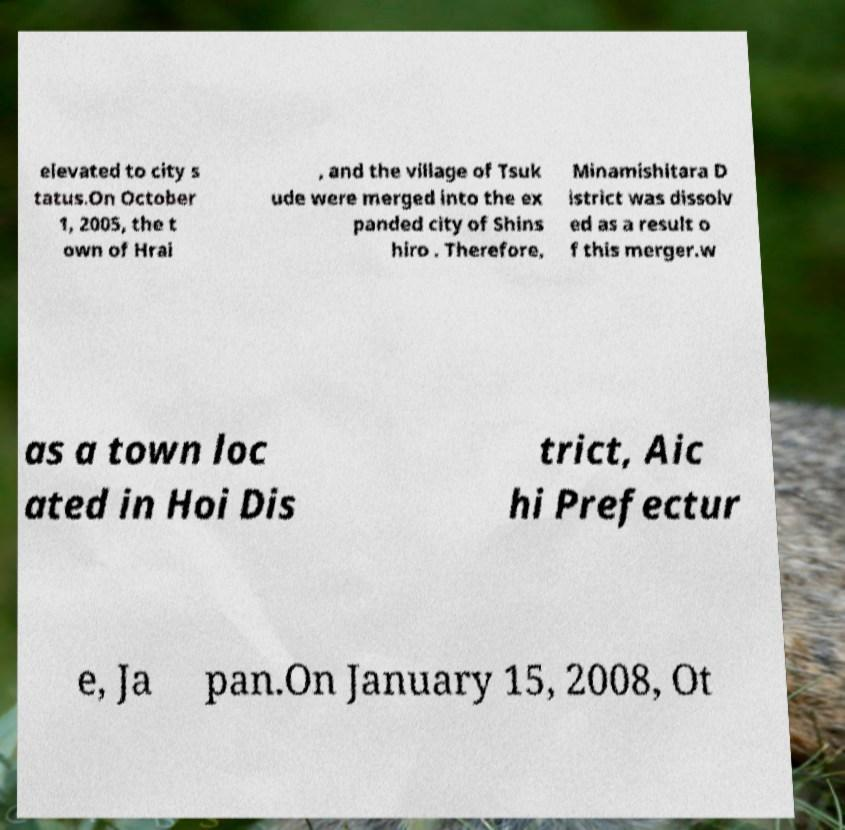Can you read and provide the text displayed in the image?This photo seems to have some interesting text. Can you extract and type it out for me? elevated to city s tatus.On October 1, 2005, the t own of Hrai , and the village of Tsuk ude were merged into the ex panded city of Shins hiro . Therefore, Minamishitara D istrict was dissolv ed as a result o f this merger.w as a town loc ated in Hoi Dis trict, Aic hi Prefectur e, Ja pan.On January 15, 2008, Ot 